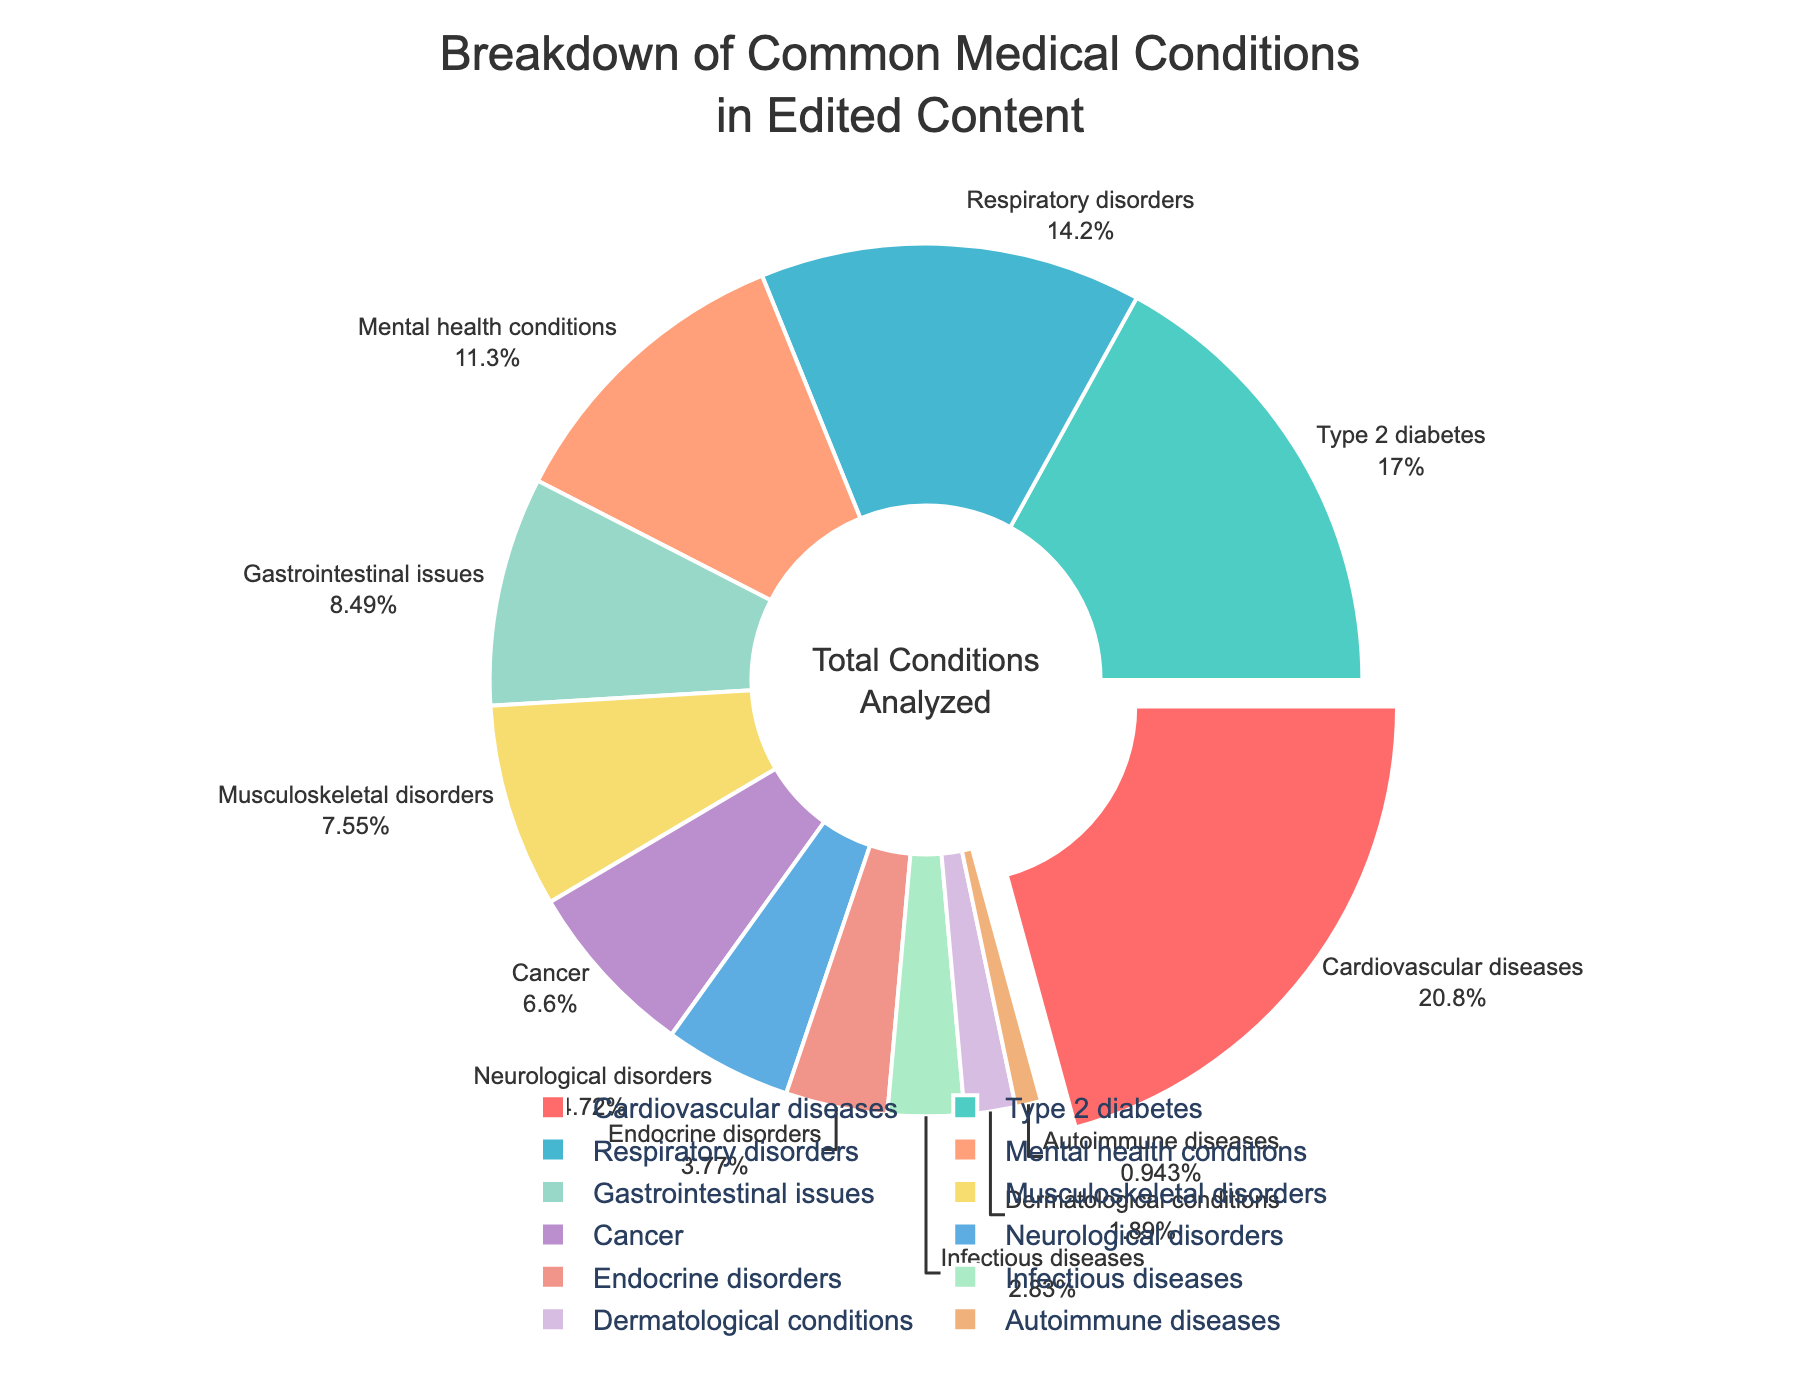Which medical condition has the highest percentage coverage? The pie chart shows that "Cardiovascular diseases" has the largest segment with 22% coverage, which is higher than any other condition.
Answer: Cardiovascular diseases Which conditions have less than 5% representation? The conditions with less than 5% representation are the ones with comparably smaller segments: "Neurological disorders" (5%), "Endocrine disorders" (4%), "Infectious diseases" (3%), "Dermatological conditions" (2%), and "Autoimmune diseases" (1%).
Answer: Neurological disorders, Endocrine disorders, Infectious diseases, Dermatological conditions, Autoimmune diseases How much larger is the percentage of Cardiovascular diseases compared to Cancer? Cardiovascular diseases have a percentage of 22%, whereas Cancer has 7%. The difference in their representation is 22% - 7%, which equals 15%.
Answer: 15% What is the combined percentage of Respiratory disorders and Mental health conditions? Respiratory disorders and Mental health conditions have percentages of 15% and 12%, respectively. Adding these gives 15% + 12% = 27%.
Answer: 27% Which condition has the smallest representation, and what is its percentage? The condition with the smallest pie segment is "Autoimmune diseases," indicated by the outer label showing 1%.
Answer: Autoimmune diseases How many conditions have a percentage greater than 10%? The conditions with greater than 10% are those with segments larger than 10%. They are Cardiovascular diseases (22%), Type 2 diabetes (18%), Respiratory disorders (15%), and Mental health conditions (12%). In total, there are 4 conditions.
Answer: 4 What is the total percentage covered by Gastrointestinal issues and Musculoskeletal disorders combined? Gastrointestinal issues cover 9% and Musculoskeletal disorders cover 8%. Adding these together gives 9% + 8% = 17%.
Answer: 17% Which conditions are colored in shades of blue and green in the pie chart? By examining the colors used in the pie chart, Type 2 diabetes is in light green, Respiratory disorders is in teal, and Neurological disorders is in light blue.
Answer: Type 2 diabetes, Respiratory disorders, Neurological disorders 